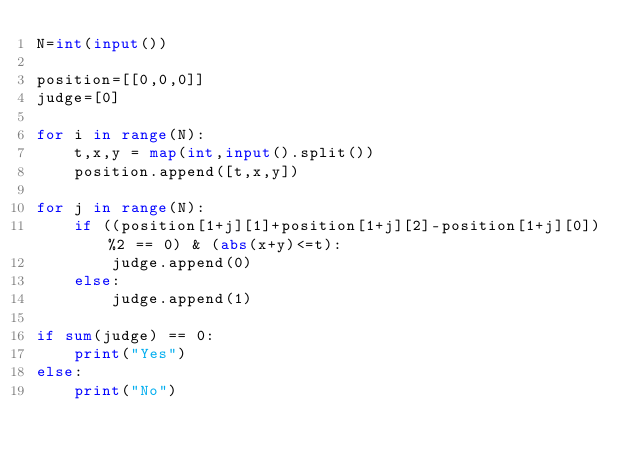Convert code to text. <code><loc_0><loc_0><loc_500><loc_500><_Python_>N=int(input())

position=[[0,0,0]]
judge=[0]

for i in range(N):
    t,x,y = map(int,input().split())
    position.append([t,x,y])

for j in range(N):
    if ((position[1+j][1]+position[1+j][2]-position[1+j][0])%2 == 0) & (abs(x+y)<=t):
        judge.append(0)
    else:
        judge.append(1)

if sum(judge) == 0:
    print("Yes")
else:
    print("No")</code> 